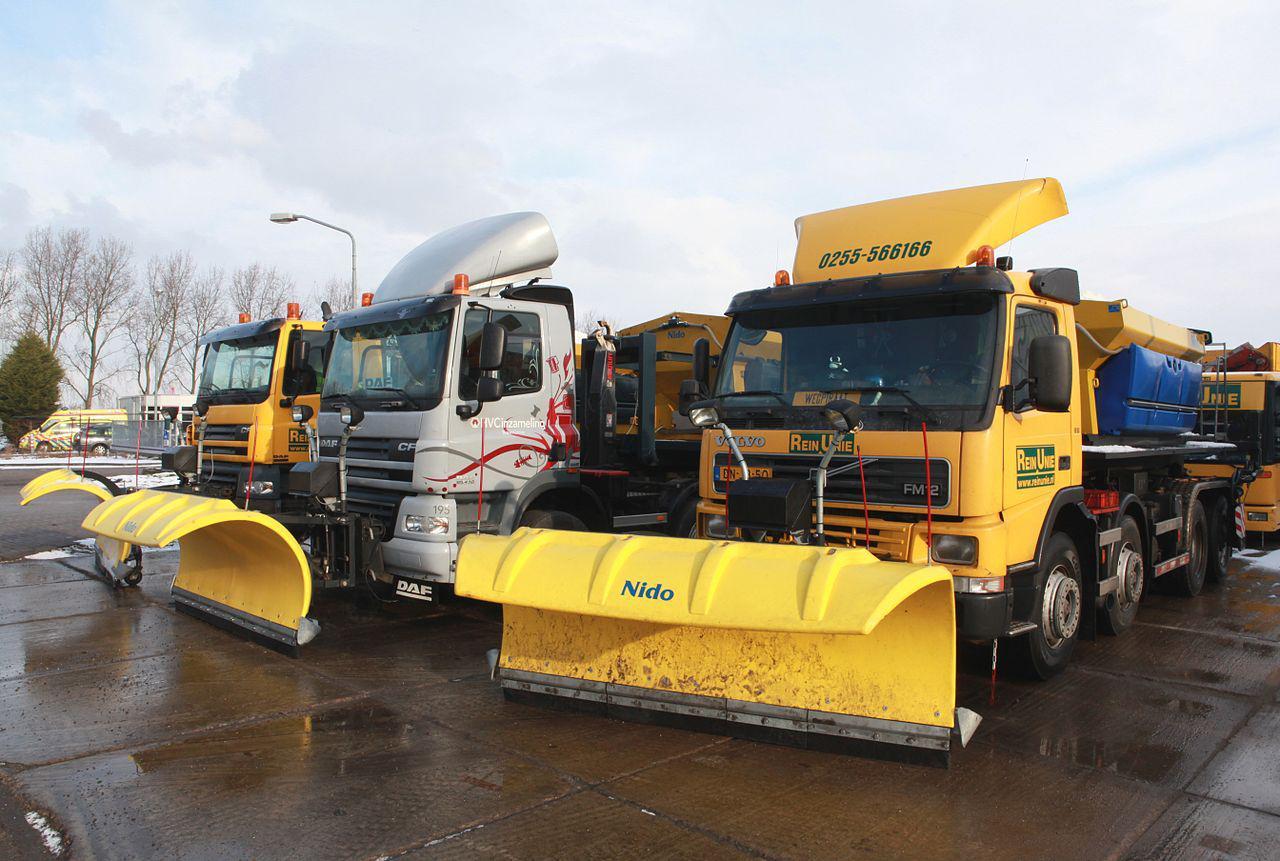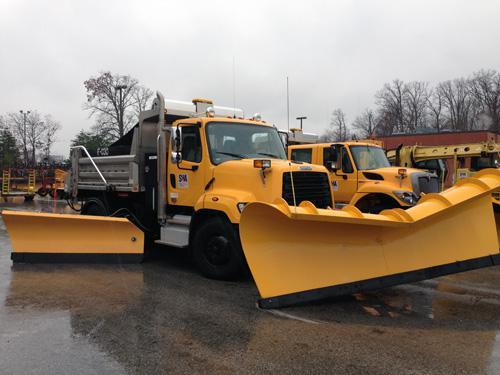The first image is the image on the left, the second image is the image on the right. Assess this claim about the two images: "The image on the left contains exactly one yellow truck". Correct or not? Answer yes or no. No. 